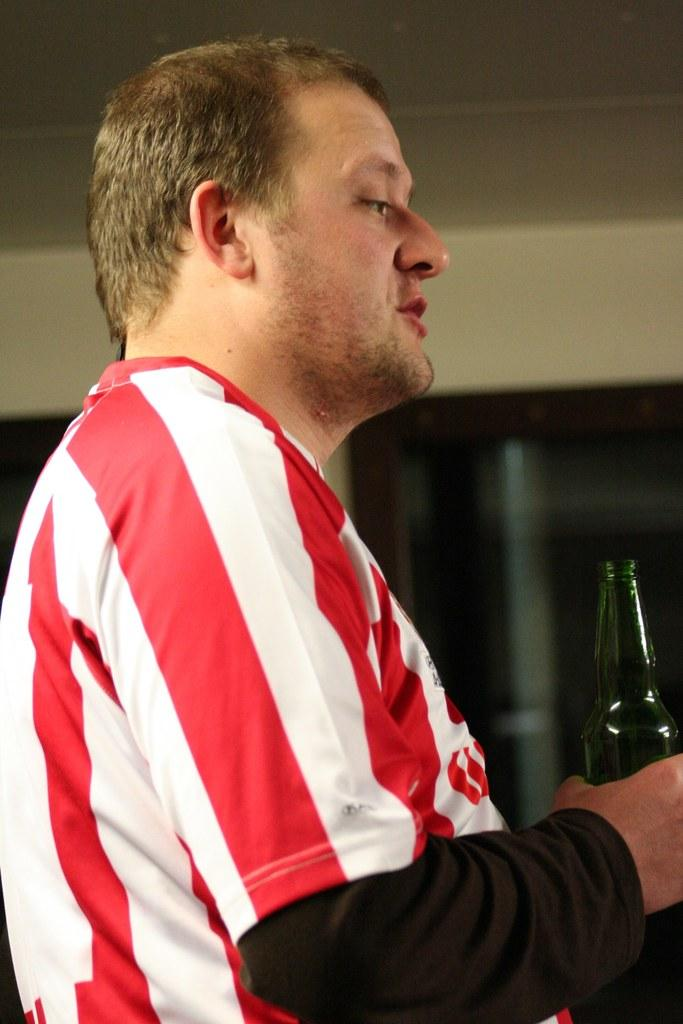Who is present in the image? There is a man in the image. What is the man holding in his hand? The man is holding a bottle in his hand. What type of branch is the man holding in the image? There is no branch present in the image; the man is holding a bottle. 